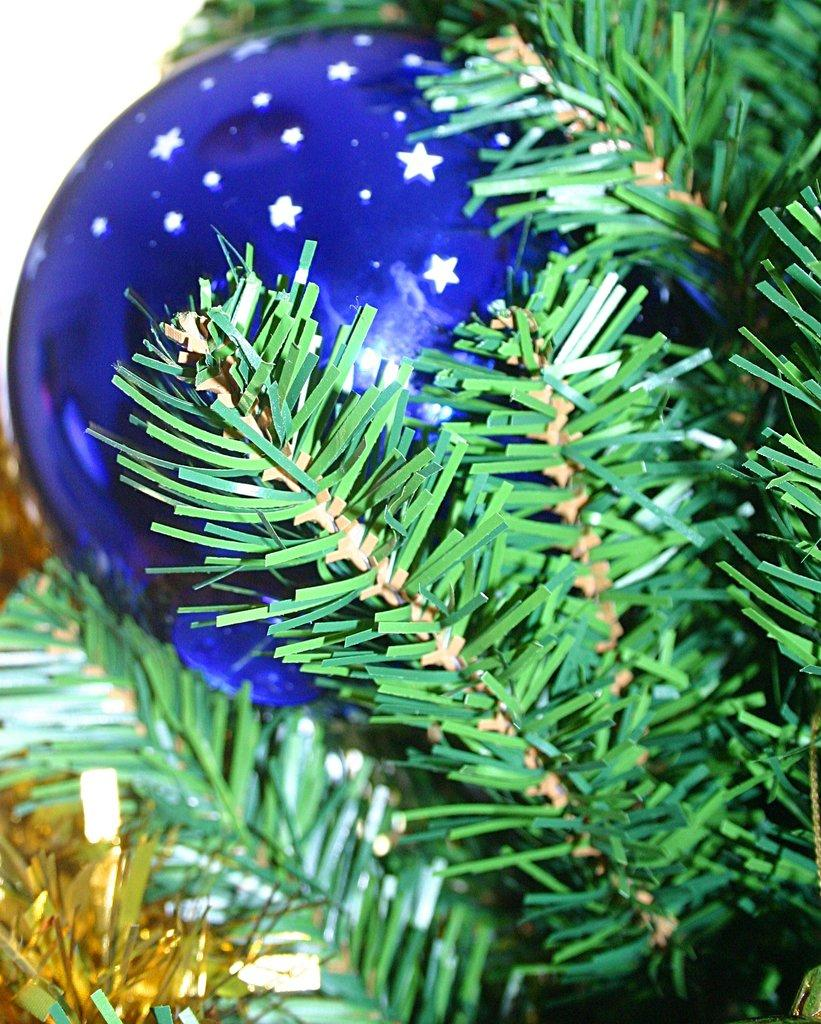What type of toy is featured in the image? There is a blue Christmas toy ball in the image. What other object can be seen in the image besides the toy? There is a plant in the image. What type of detail can be seen on the operation of the toy in the image? There is no operation or detail about the operation of the toy visible in the image, as it is a static toy ball. 